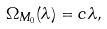Convert formula to latex. <formula><loc_0><loc_0><loc_500><loc_500>\Omega _ { M _ { 0 } } ( \lambda ) = c \lambda ,</formula> 